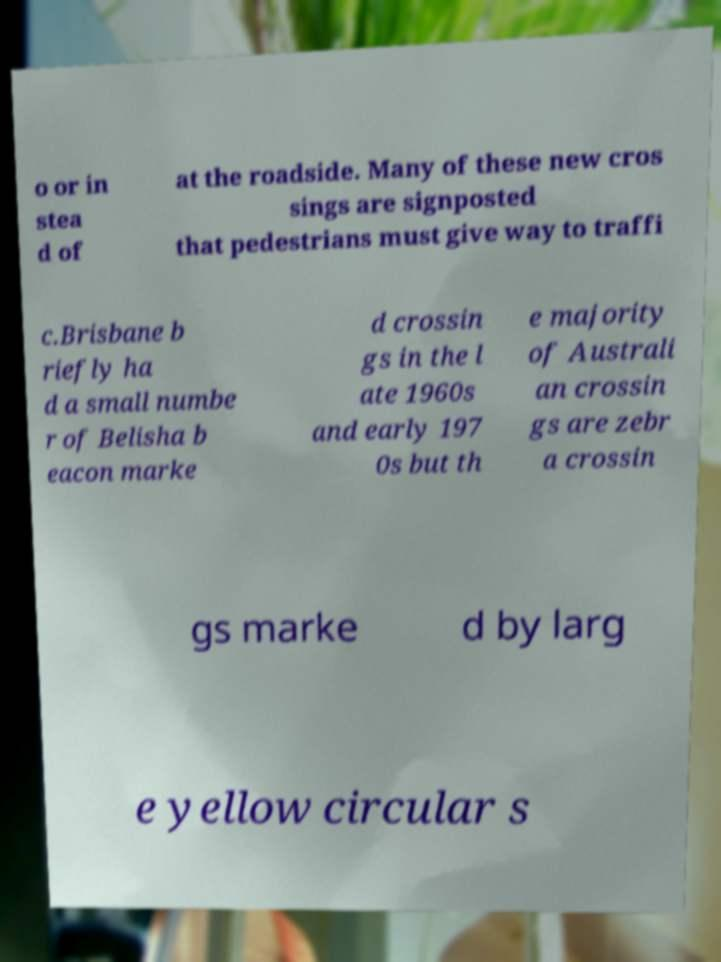Could you extract and type out the text from this image? o or in stea d of at the roadside. Many of these new cros sings are signposted that pedestrians must give way to traffi c.Brisbane b riefly ha d a small numbe r of Belisha b eacon marke d crossin gs in the l ate 1960s and early 197 0s but th e majority of Australi an crossin gs are zebr a crossin gs marke d by larg e yellow circular s 